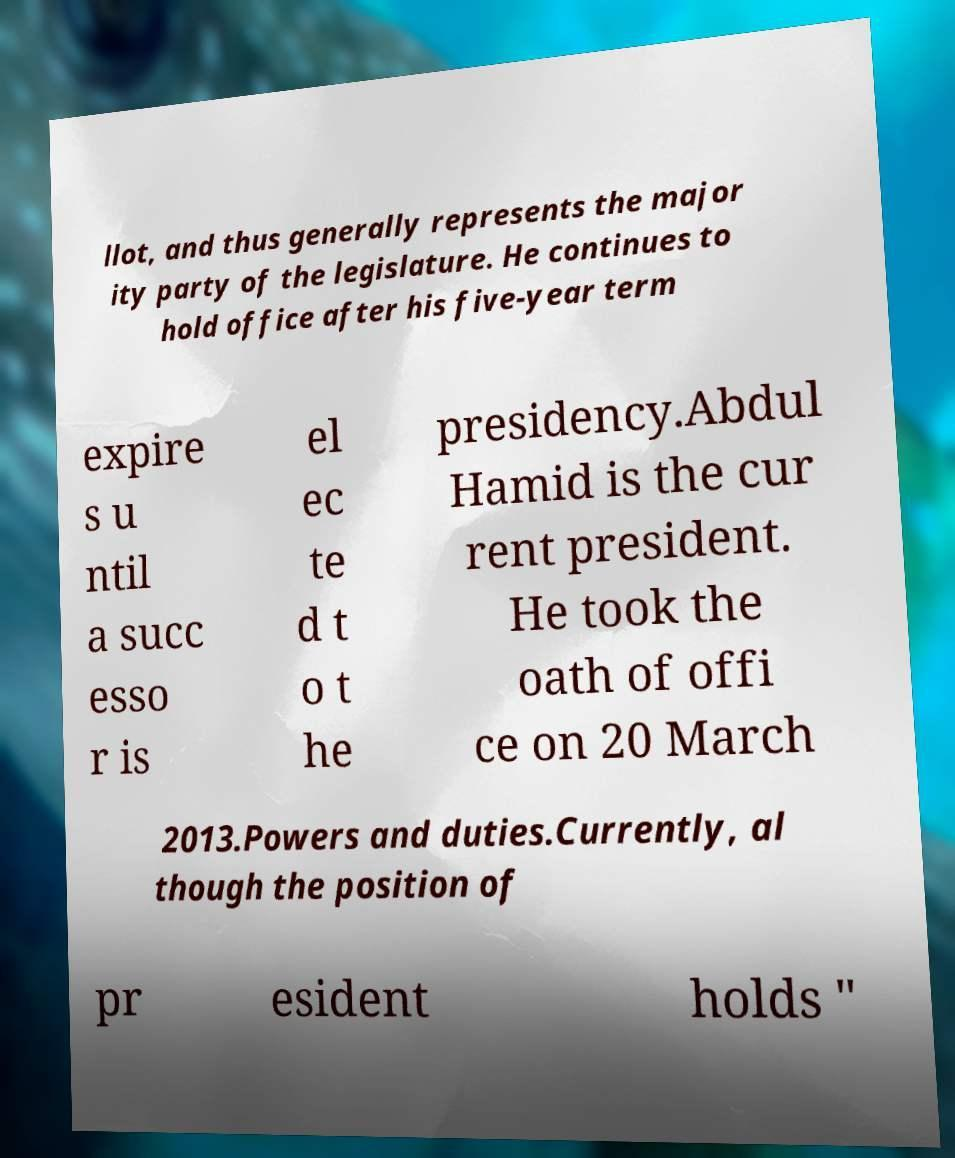I need the written content from this picture converted into text. Can you do that? llot, and thus generally represents the major ity party of the legislature. He continues to hold office after his five-year term expire s u ntil a succ esso r is el ec te d t o t he presidency.Abdul Hamid is the cur rent president. He took the oath of offi ce on 20 March 2013.Powers and duties.Currently, al though the position of pr esident holds " 